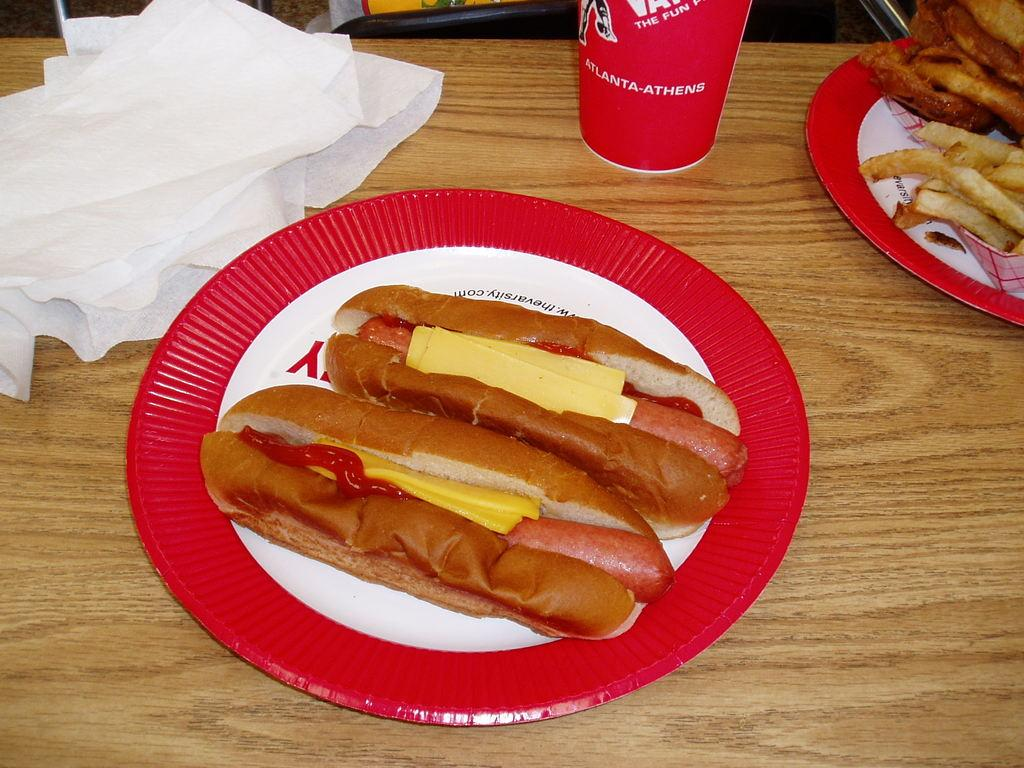What piece of furniture is present in the image? There is a table in the image. How many plates are on the table? There are two plates on the table. What type of dishware is on the table? There is a glass on the table. What else can be found on the table? There are papers on the table. What food items are on the plates? There are two hot dogs in one of the plates, and there are finger chips in the other plate. What type of hammer is being used to fix the space shuttle in the image? There is no hammer or space shuttle present in the image. 